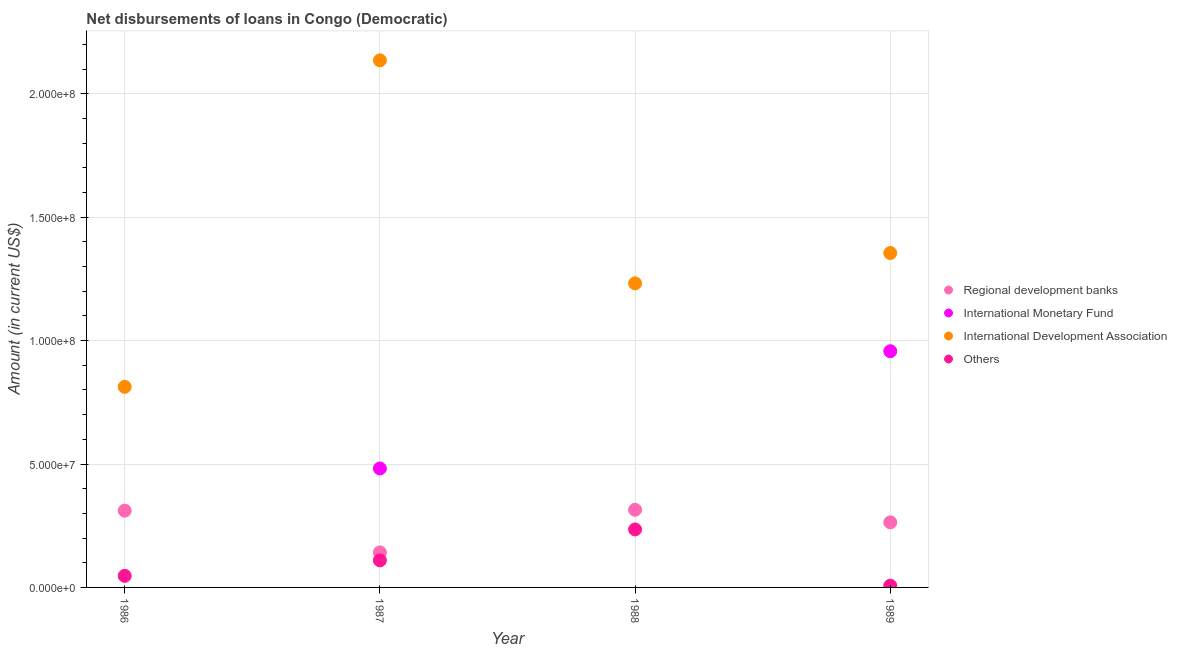Is the number of dotlines equal to the number of legend labels?
Your answer should be compact. No. What is the amount of loan disimbursed by regional development banks in 1986?
Give a very brief answer. 3.11e+07. Across all years, what is the maximum amount of loan disimbursed by international development association?
Offer a terse response. 2.14e+08. Across all years, what is the minimum amount of loan disimbursed by other organisations?
Offer a terse response. 6.95e+05. In which year was the amount of loan disimbursed by regional development banks maximum?
Ensure brevity in your answer.  1988. What is the total amount of loan disimbursed by other organisations in the graph?
Provide a succinct answer. 3.98e+07. What is the difference between the amount of loan disimbursed by international development association in 1988 and that in 1989?
Your answer should be very brief. -1.23e+07. What is the difference between the amount of loan disimbursed by regional development banks in 1987 and the amount of loan disimbursed by international monetary fund in 1986?
Give a very brief answer. 1.42e+07. What is the average amount of loan disimbursed by other organisations per year?
Ensure brevity in your answer.  9.96e+06. In the year 1986, what is the difference between the amount of loan disimbursed by international development association and amount of loan disimbursed by regional development banks?
Ensure brevity in your answer.  5.02e+07. In how many years, is the amount of loan disimbursed by international monetary fund greater than 50000000 US$?
Give a very brief answer. 1. What is the ratio of the amount of loan disimbursed by international monetary fund in 1987 to that in 1989?
Offer a very short reply. 0.5. Is the amount of loan disimbursed by regional development banks in 1986 less than that in 1988?
Give a very brief answer. Yes. What is the difference between the highest and the second highest amount of loan disimbursed by regional development banks?
Give a very brief answer. 3.65e+05. What is the difference between the highest and the lowest amount of loan disimbursed by international monetary fund?
Keep it short and to the point. 9.57e+07. Does the amount of loan disimbursed by regional development banks monotonically increase over the years?
Your response must be concise. No. Is the amount of loan disimbursed by international monetary fund strictly greater than the amount of loan disimbursed by other organisations over the years?
Provide a succinct answer. No. Is the amount of loan disimbursed by regional development banks strictly less than the amount of loan disimbursed by international monetary fund over the years?
Your answer should be very brief. No. How many years are there in the graph?
Offer a very short reply. 4. Are the values on the major ticks of Y-axis written in scientific E-notation?
Your answer should be compact. Yes. Does the graph contain any zero values?
Ensure brevity in your answer.  Yes. Where does the legend appear in the graph?
Give a very brief answer. Center right. How many legend labels are there?
Provide a short and direct response. 4. What is the title of the graph?
Your answer should be compact. Net disbursements of loans in Congo (Democratic). What is the Amount (in current US$) of Regional development banks in 1986?
Provide a short and direct response. 3.11e+07. What is the Amount (in current US$) of International Development Association in 1986?
Your answer should be compact. 8.13e+07. What is the Amount (in current US$) in Others in 1986?
Ensure brevity in your answer.  4.69e+06. What is the Amount (in current US$) of Regional development banks in 1987?
Keep it short and to the point. 1.42e+07. What is the Amount (in current US$) in International Monetary Fund in 1987?
Your response must be concise. 4.82e+07. What is the Amount (in current US$) of International Development Association in 1987?
Offer a very short reply. 2.14e+08. What is the Amount (in current US$) of Others in 1987?
Offer a terse response. 1.10e+07. What is the Amount (in current US$) in Regional development banks in 1988?
Your response must be concise. 3.15e+07. What is the Amount (in current US$) of International Monetary Fund in 1988?
Give a very brief answer. 0. What is the Amount (in current US$) in International Development Association in 1988?
Your answer should be compact. 1.23e+08. What is the Amount (in current US$) of Others in 1988?
Your answer should be compact. 2.35e+07. What is the Amount (in current US$) in Regional development banks in 1989?
Ensure brevity in your answer.  2.64e+07. What is the Amount (in current US$) of International Monetary Fund in 1989?
Make the answer very short. 9.57e+07. What is the Amount (in current US$) in International Development Association in 1989?
Your answer should be very brief. 1.35e+08. What is the Amount (in current US$) in Others in 1989?
Offer a very short reply. 6.95e+05. Across all years, what is the maximum Amount (in current US$) of Regional development banks?
Your response must be concise. 3.15e+07. Across all years, what is the maximum Amount (in current US$) in International Monetary Fund?
Make the answer very short. 9.57e+07. Across all years, what is the maximum Amount (in current US$) in International Development Association?
Your response must be concise. 2.14e+08. Across all years, what is the maximum Amount (in current US$) of Others?
Your answer should be very brief. 2.35e+07. Across all years, what is the minimum Amount (in current US$) of Regional development banks?
Ensure brevity in your answer.  1.42e+07. Across all years, what is the minimum Amount (in current US$) in International Development Association?
Make the answer very short. 8.13e+07. Across all years, what is the minimum Amount (in current US$) in Others?
Offer a terse response. 6.95e+05. What is the total Amount (in current US$) in Regional development banks in the graph?
Keep it short and to the point. 1.03e+08. What is the total Amount (in current US$) in International Monetary Fund in the graph?
Your answer should be very brief. 1.44e+08. What is the total Amount (in current US$) in International Development Association in the graph?
Your answer should be compact. 5.54e+08. What is the total Amount (in current US$) of Others in the graph?
Offer a terse response. 3.98e+07. What is the difference between the Amount (in current US$) in Regional development banks in 1986 and that in 1987?
Ensure brevity in your answer.  1.69e+07. What is the difference between the Amount (in current US$) of International Development Association in 1986 and that in 1987?
Offer a very short reply. -1.32e+08. What is the difference between the Amount (in current US$) of Others in 1986 and that in 1987?
Your answer should be very brief. -6.26e+06. What is the difference between the Amount (in current US$) of Regional development banks in 1986 and that in 1988?
Provide a succinct answer. -3.65e+05. What is the difference between the Amount (in current US$) in International Development Association in 1986 and that in 1988?
Make the answer very short. -4.19e+07. What is the difference between the Amount (in current US$) of Others in 1986 and that in 1988?
Your answer should be very brief. -1.88e+07. What is the difference between the Amount (in current US$) in Regional development banks in 1986 and that in 1989?
Offer a terse response. 4.74e+06. What is the difference between the Amount (in current US$) in International Development Association in 1986 and that in 1989?
Offer a terse response. -5.42e+07. What is the difference between the Amount (in current US$) of Others in 1986 and that in 1989?
Offer a very short reply. 4.00e+06. What is the difference between the Amount (in current US$) in Regional development banks in 1987 and that in 1988?
Offer a terse response. -1.73e+07. What is the difference between the Amount (in current US$) of International Development Association in 1987 and that in 1988?
Your answer should be very brief. 9.04e+07. What is the difference between the Amount (in current US$) of Others in 1987 and that in 1988?
Provide a short and direct response. -1.25e+07. What is the difference between the Amount (in current US$) in Regional development banks in 1987 and that in 1989?
Keep it short and to the point. -1.22e+07. What is the difference between the Amount (in current US$) of International Monetary Fund in 1987 and that in 1989?
Keep it short and to the point. -4.75e+07. What is the difference between the Amount (in current US$) of International Development Association in 1987 and that in 1989?
Offer a very short reply. 7.81e+07. What is the difference between the Amount (in current US$) in Others in 1987 and that in 1989?
Your answer should be very brief. 1.03e+07. What is the difference between the Amount (in current US$) of Regional development banks in 1988 and that in 1989?
Your answer should be very brief. 5.10e+06. What is the difference between the Amount (in current US$) in International Development Association in 1988 and that in 1989?
Your answer should be very brief. -1.23e+07. What is the difference between the Amount (in current US$) in Others in 1988 and that in 1989?
Keep it short and to the point. 2.28e+07. What is the difference between the Amount (in current US$) of Regional development banks in 1986 and the Amount (in current US$) of International Monetary Fund in 1987?
Ensure brevity in your answer.  -1.71e+07. What is the difference between the Amount (in current US$) in Regional development banks in 1986 and the Amount (in current US$) in International Development Association in 1987?
Ensure brevity in your answer.  -1.82e+08. What is the difference between the Amount (in current US$) in Regional development banks in 1986 and the Amount (in current US$) in Others in 1987?
Your answer should be very brief. 2.02e+07. What is the difference between the Amount (in current US$) of International Development Association in 1986 and the Amount (in current US$) of Others in 1987?
Give a very brief answer. 7.03e+07. What is the difference between the Amount (in current US$) of Regional development banks in 1986 and the Amount (in current US$) of International Development Association in 1988?
Provide a short and direct response. -9.21e+07. What is the difference between the Amount (in current US$) of Regional development banks in 1986 and the Amount (in current US$) of Others in 1988?
Keep it short and to the point. 7.61e+06. What is the difference between the Amount (in current US$) in International Development Association in 1986 and the Amount (in current US$) in Others in 1988?
Keep it short and to the point. 5.78e+07. What is the difference between the Amount (in current US$) in Regional development banks in 1986 and the Amount (in current US$) in International Monetary Fund in 1989?
Offer a terse response. -6.46e+07. What is the difference between the Amount (in current US$) of Regional development banks in 1986 and the Amount (in current US$) of International Development Association in 1989?
Offer a terse response. -1.04e+08. What is the difference between the Amount (in current US$) of Regional development banks in 1986 and the Amount (in current US$) of Others in 1989?
Give a very brief answer. 3.04e+07. What is the difference between the Amount (in current US$) in International Development Association in 1986 and the Amount (in current US$) in Others in 1989?
Ensure brevity in your answer.  8.06e+07. What is the difference between the Amount (in current US$) in Regional development banks in 1987 and the Amount (in current US$) in International Development Association in 1988?
Your answer should be very brief. -1.09e+08. What is the difference between the Amount (in current US$) of Regional development banks in 1987 and the Amount (in current US$) of Others in 1988?
Provide a short and direct response. -9.31e+06. What is the difference between the Amount (in current US$) of International Monetary Fund in 1987 and the Amount (in current US$) of International Development Association in 1988?
Offer a terse response. -7.50e+07. What is the difference between the Amount (in current US$) of International Monetary Fund in 1987 and the Amount (in current US$) of Others in 1988?
Ensure brevity in your answer.  2.47e+07. What is the difference between the Amount (in current US$) in International Development Association in 1987 and the Amount (in current US$) in Others in 1988?
Make the answer very short. 1.90e+08. What is the difference between the Amount (in current US$) of Regional development banks in 1987 and the Amount (in current US$) of International Monetary Fund in 1989?
Ensure brevity in your answer.  -8.15e+07. What is the difference between the Amount (in current US$) of Regional development banks in 1987 and the Amount (in current US$) of International Development Association in 1989?
Your answer should be very brief. -1.21e+08. What is the difference between the Amount (in current US$) in Regional development banks in 1987 and the Amount (in current US$) in Others in 1989?
Provide a succinct answer. 1.35e+07. What is the difference between the Amount (in current US$) in International Monetary Fund in 1987 and the Amount (in current US$) in International Development Association in 1989?
Provide a short and direct response. -8.73e+07. What is the difference between the Amount (in current US$) in International Monetary Fund in 1987 and the Amount (in current US$) in Others in 1989?
Keep it short and to the point. 4.75e+07. What is the difference between the Amount (in current US$) of International Development Association in 1987 and the Amount (in current US$) of Others in 1989?
Offer a terse response. 2.13e+08. What is the difference between the Amount (in current US$) of Regional development banks in 1988 and the Amount (in current US$) of International Monetary Fund in 1989?
Offer a very short reply. -6.42e+07. What is the difference between the Amount (in current US$) of Regional development banks in 1988 and the Amount (in current US$) of International Development Association in 1989?
Ensure brevity in your answer.  -1.04e+08. What is the difference between the Amount (in current US$) of Regional development banks in 1988 and the Amount (in current US$) of Others in 1989?
Your answer should be very brief. 3.08e+07. What is the difference between the Amount (in current US$) in International Development Association in 1988 and the Amount (in current US$) in Others in 1989?
Your answer should be very brief. 1.23e+08. What is the average Amount (in current US$) in Regional development banks per year?
Provide a succinct answer. 2.58e+07. What is the average Amount (in current US$) of International Monetary Fund per year?
Provide a succinct answer. 3.60e+07. What is the average Amount (in current US$) of International Development Association per year?
Your answer should be compact. 1.38e+08. What is the average Amount (in current US$) in Others per year?
Make the answer very short. 9.96e+06. In the year 1986, what is the difference between the Amount (in current US$) in Regional development banks and Amount (in current US$) in International Development Association?
Give a very brief answer. -5.02e+07. In the year 1986, what is the difference between the Amount (in current US$) in Regional development banks and Amount (in current US$) in Others?
Offer a terse response. 2.64e+07. In the year 1986, what is the difference between the Amount (in current US$) in International Development Association and Amount (in current US$) in Others?
Offer a terse response. 7.66e+07. In the year 1987, what is the difference between the Amount (in current US$) of Regional development banks and Amount (in current US$) of International Monetary Fund?
Offer a terse response. -3.40e+07. In the year 1987, what is the difference between the Amount (in current US$) in Regional development banks and Amount (in current US$) in International Development Association?
Ensure brevity in your answer.  -1.99e+08. In the year 1987, what is the difference between the Amount (in current US$) in Regional development banks and Amount (in current US$) in Others?
Keep it short and to the point. 3.24e+06. In the year 1987, what is the difference between the Amount (in current US$) in International Monetary Fund and Amount (in current US$) in International Development Association?
Make the answer very short. -1.65e+08. In the year 1987, what is the difference between the Amount (in current US$) of International Monetary Fund and Amount (in current US$) of Others?
Ensure brevity in your answer.  3.72e+07. In the year 1987, what is the difference between the Amount (in current US$) in International Development Association and Amount (in current US$) in Others?
Keep it short and to the point. 2.03e+08. In the year 1988, what is the difference between the Amount (in current US$) of Regional development banks and Amount (in current US$) of International Development Association?
Offer a terse response. -9.17e+07. In the year 1988, what is the difference between the Amount (in current US$) in Regional development banks and Amount (in current US$) in Others?
Provide a short and direct response. 7.97e+06. In the year 1988, what is the difference between the Amount (in current US$) of International Development Association and Amount (in current US$) of Others?
Ensure brevity in your answer.  9.97e+07. In the year 1989, what is the difference between the Amount (in current US$) in Regional development banks and Amount (in current US$) in International Monetary Fund?
Ensure brevity in your answer.  -6.93e+07. In the year 1989, what is the difference between the Amount (in current US$) in Regional development banks and Amount (in current US$) in International Development Association?
Keep it short and to the point. -1.09e+08. In the year 1989, what is the difference between the Amount (in current US$) in Regional development banks and Amount (in current US$) in Others?
Your answer should be very brief. 2.57e+07. In the year 1989, what is the difference between the Amount (in current US$) of International Monetary Fund and Amount (in current US$) of International Development Association?
Provide a succinct answer. -3.98e+07. In the year 1989, what is the difference between the Amount (in current US$) of International Monetary Fund and Amount (in current US$) of Others?
Provide a succinct answer. 9.50e+07. In the year 1989, what is the difference between the Amount (in current US$) in International Development Association and Amount (in current US$) in Others?
Provide a short and direct response. 1.35e+08. What is the ratio of the Amount (in current US$) in Regional development banks in 1986 to that in 1987?
Your response must be concise. 2.19. What is the ratio of the Amount (in current US$) in International Development Association in 1986 to that in 1987?
Offer a very short reply. 0.38. What is the ratio of the Amount (in current US$) in Others in 1986 to that in 1987?
Provide a succinct answer. 0.43. What is the ratio of the Amount (in current US$) in Regional development banks in 1986 to that in 1988?
Keep it short and to the point. 0.99. What is the ratio of the Amount (in current US$) of International Development Association in 1986 to that in 1988?
Make the answer very short. 0.66. What is the ratio of the Amount (in current US$) of Others in 1986 to that in 1988?
Offer a very short reply. 0.2. What is the ratio of the Amount (in current US$) in Regional development banks in 1986 to that in 1989?
Your answer should be compact. 1.18. What is the ratio of the Amount (in current US$) in International Development Association in 1986 to that in 1989?
Your response must be concise. 0.6. What is the ratio of the Amount (in current US$) in Others in 1986 to that in 1989?
Ensure brevity in your answer.  6.75. What is the ratio of the Amount (in current US$) in Regional development banks in 1987 to that in 1988?
Offer a very short reply. 0.45. What is the ratio of the Amount (in current US$) in International Development Association in 1987 to that in 1988?
Provide a succinct answer. 1.73. What is the ratio of the Amount (in current US$) in Others in 1987 to that in 1988?
Give a very brief answer. 0.47. What is the ratio of the Amount (in current US$) of Regional development banks in 1987 to that in 1989?
Your response must be concise. 0.54. What is the ratio of the Amount (in current US$) in International Monetary Fund in 1987 to that in 1989?
Your answer should be very brief. 0.5. What is the ratio of the Amount (in current US$) in International Development Association in 1987 to that in 1989?
Your response must be concise. 1.58. What is the ratio of the Amount (in current US$) in Others in 1987 to that in 1989?
Provide a succinct answer. 15.76. What is the ratio of the Amount (in current US$) in Regional development banks in 1988 to that in 1989?
Provide a short and direct response. 1.19. What is the ratio of the Amount (in current US$) in International Development Association in 1988 to that in 1989?
Your answer should be very brief. 0.91. What is the ratio of the Amount (in current US$) of Others in 1988 to that in 1989?
Give a very brief answer. 33.81. What is the difference between the highest and the second highest Amount (in current US$) of Regional development banks?
Provide a succinct answer. 3.65e+05. What is the difference between the highest and the second highest Amount (in current US$) in International Development Association?
Make the answer very short. 7.81e+07. What is the difference between the highest and the second highest Amount (in current US$) of Others?
Make the answer very short. 1.25e+07. What is the difference between the highest and the lowest Amount (in current US$) of Regional development banks?
Offer a terse response. 1.73e+07. What is the difference between the highest and the lowest Amount (in current US$) in International Monetary Fund?
Make the answer very short. 9.57e+07. What is the difference between the highest and the lowest Amount (in current US$) in International Development Association?
Make the answer very short. 1.32e+08. What is the difference between the highest and the lowest Amount (in current US$) of Others?
Ensure brevity in your answer.  2.28e+07. 